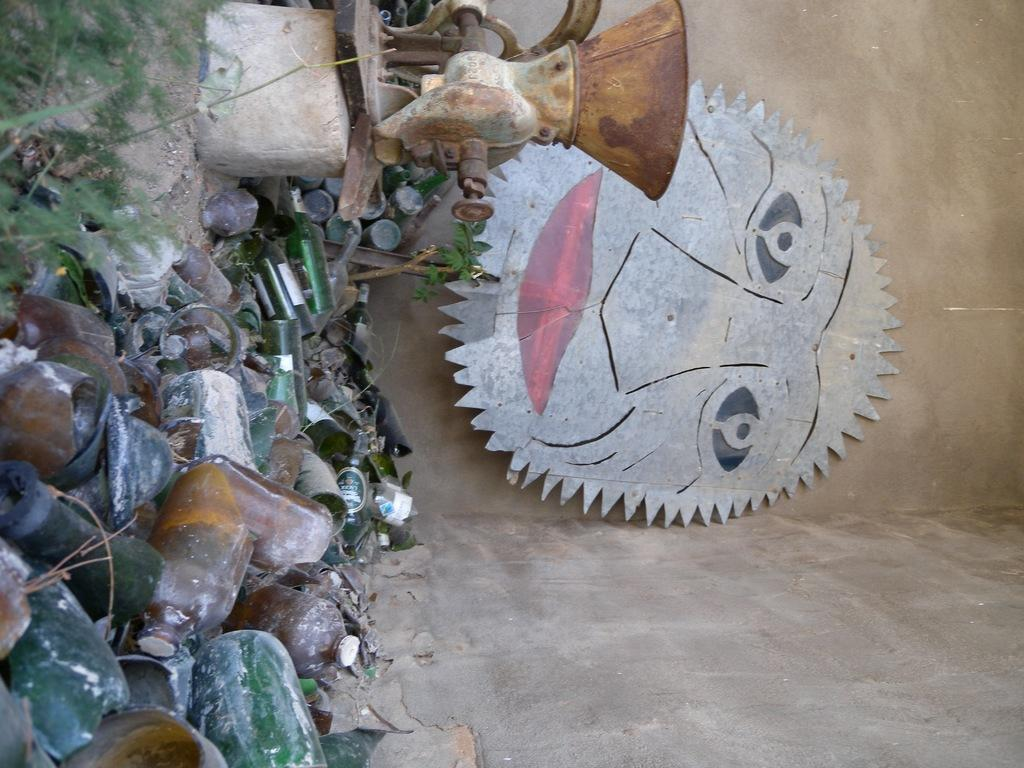What objects can be seen in the image? There are bottles and a machine in the image. What type of surface is visible on the ground? There is grass on the ground in the image. What architectural feature can be seen in the image? There is a wall visible in the image. What type of soup is being prepared in the wilderness in the image? There is no soup or wilderness present in the image; it features bottles, a machine, grass, and a wall. 